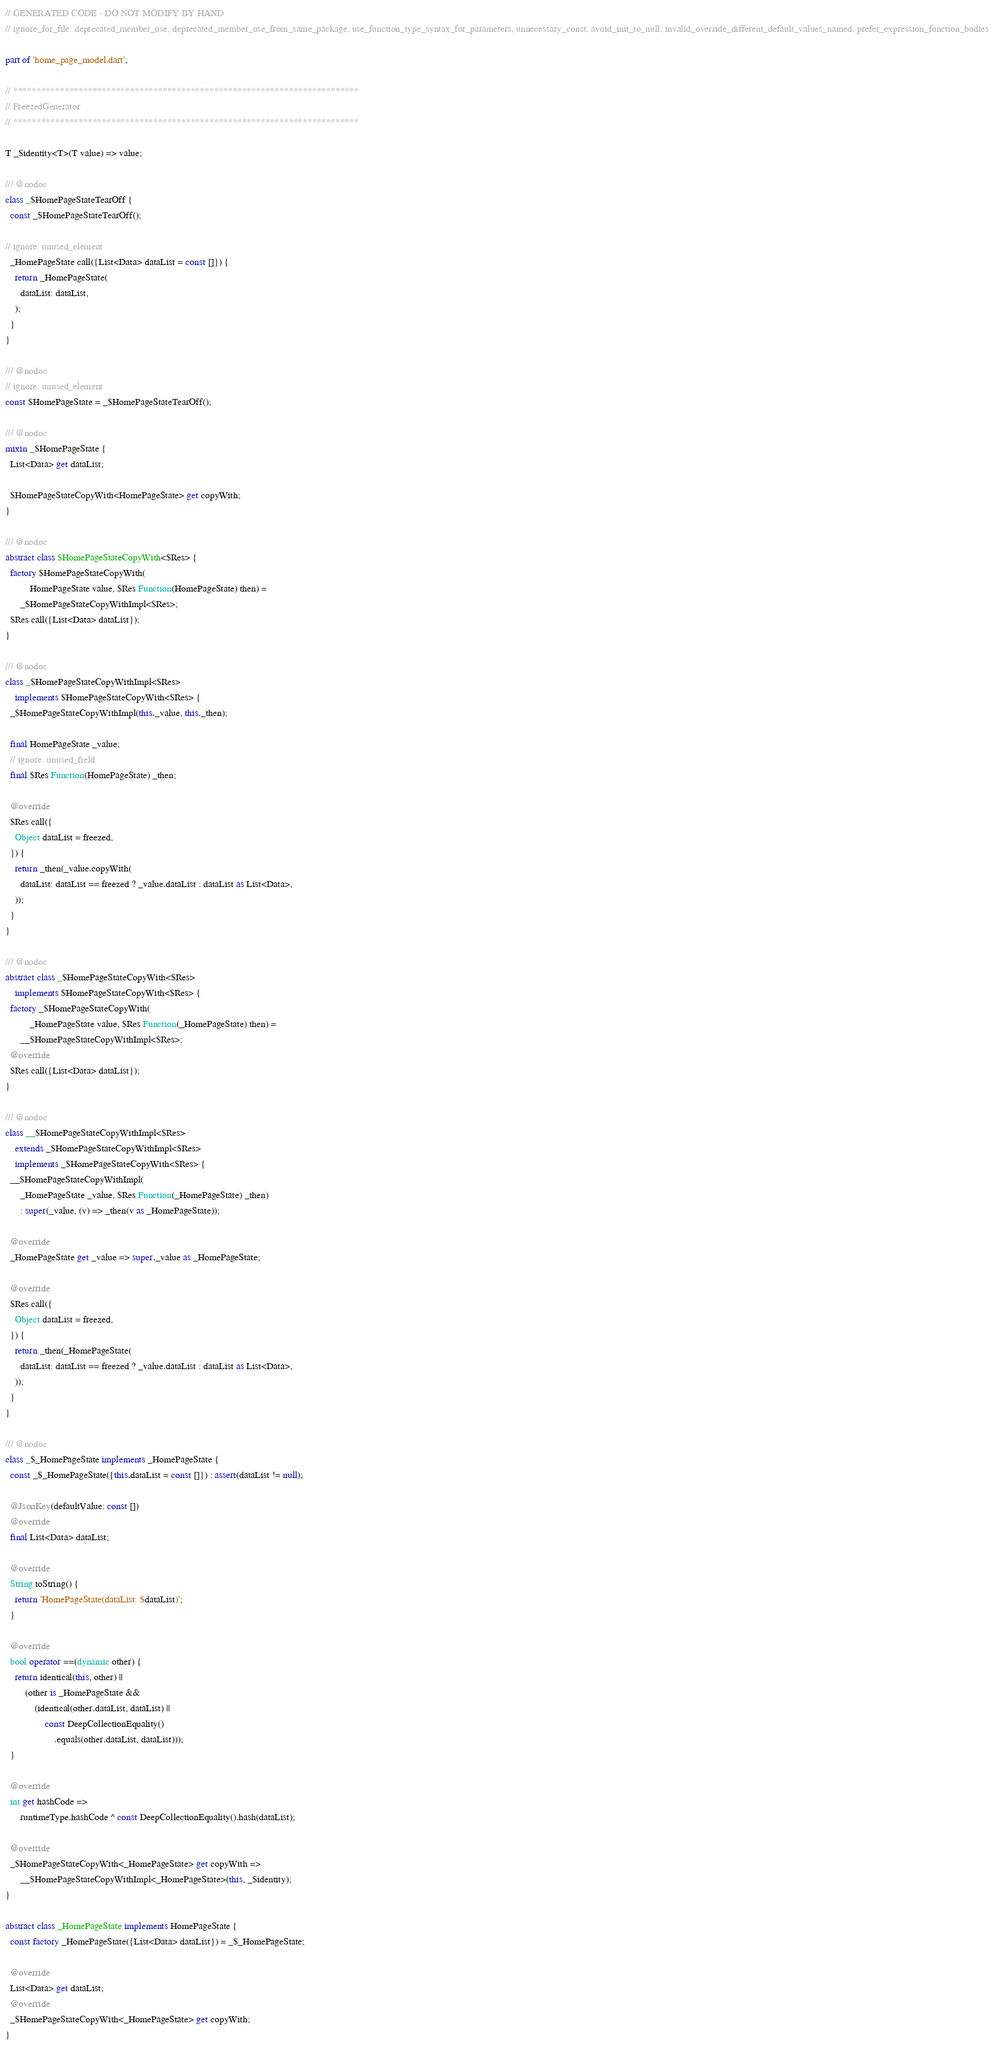Convert code to text. <code><loc_0><loc_0><loc_500><loc_500><_Dart_>// GENERATED CODE - DO NOT MODIFY BY HAND
// ignore_for_file: deprecated_member_use, deprecated_member_use_from_same_package, use_function_type_syntax_for_parameters, unnecessary_const, avoid_init_to_null, invalid_override_different_default_values_named, prefer_expression_function_bodies

part of 'home_page_model.dart';

// **************************************************************************
// FreezedGenerator
// **************************************************************************

T _$identity<T>(T value) => value;

/// @nodoc
class _$HomePageStateTearOff {
  const _$HomePageStateTearOff();

// ignore: unused_element
  _HomePageState call({List<Data> dataList = const []}) {
    return _HomePageState(
      dataList: dataList,
    );
  }
}

/// @nodoc
// ignore: unused_element
const $HomePageState = _$HomePageStateTearOff();

/// @nodoc
mixin _$HomePageState {
  List<Data> get dataList;

  $HomePageStateCopyWith<HomePageState> get copyWith;
}

/// @nodoc
abstract class $HomePageStateCopyWith<$Res> {
  factory $HomePageStateCopyWith(
          HomePageState value, $Res Function(HomePageState) then) =
      _$HomePageStateCopyWithImpl<$Res>;
  $Res call({List<Data> dataList});
}

/// @nodoc
class _$HomePageStateCopyWithImpl<$Res>
    implements $HomePageStateCopyWith<$Res> {
  _$HomePageStateCopyWithImpl(this._value, this._then);

  final HomePageState _value;
  // ignore: unused_field
  final $Res Function(HomePageState) _then;

  @override
  $Res call({
    Object dataList = freezed,
  }) {
    return _then(_value.copyWith(
      dataList: dataList == freezed ? _value.dataList : dataList as List<Data>,
    ));
  }
}

/// @nodoc
abstract class _$HomePageStateCopyWith<$Res>
    implements $HomePageStateCopyWith<$Res> {
  factory _$HomePageStateCopyWith(
          _HomePageState value, $Res Function(_HomePageState) then) =
      __$HomePageStateCopyWithImpl<$Res>;
  @override
  $Res call({List<Data> dataList});
}

/// @nodoc
class __$HomePageStateCopyWithImpl<$Res>
    extends _$HomePageStateCopyWithImpl<$Res>
    implements _$HomePageStateCopyWith<$Res> {
  __$HomePageStateCopyWithImpl(
      _HomePageState _value, $Res Function(_HomePageState) _then)
      : super(_value, (v) => _then(v as _HomePageState));

  @override
  _HomePageState get _value => super._value as _HomePageState;

  @override
  $Res call({
    Object dataList = freezed,
  }) {
    return _then(_HomePageState(
      dataList: dataList == freezed ? _value.dataList : dataList as List<Data>,
    ));
  }
}

/// @nodoc
class _$_HomePageState implements _HomePageState {
  const _$_HomePageState({this.dataList = const []}) : assert(dataList != null);

  @JsonKey(defaultValue: const [])
  @override
  final List<Data> dataList;

  @override
  String toString() {
    return 'HomePageState(dataList: $dataList)';
  }

  @override
  bool operator ==(dynamic other) {
    return identical(this, other) ||
        (other is _HomePageState &&
            (identical(other.dataList, dataList) ||
                const DeepCollectionEquality()
                    .equals(other.dataList, dataList)));
  }

  @override
  int get hashCode =>
      runtimeType.hashCode ^ const DeepCollectionEquality().hash(dataList);

  @override
  _$HomePageStateCopyWith<_HomePageState> get copyWith =>
      __$HomePageStateCopyWithImpl<_HomePageState>(this, _$identity);
}

abstract class _HomePageState implements HomePageState {
  const factory _HomePageState({List<Data> dataList}) = _$_HomePageState;

  @override
  List<Data> get dataList;
  @override
  _$HomePageStateCopyWith<_HomePageState> get copyWith;
}
</code> 